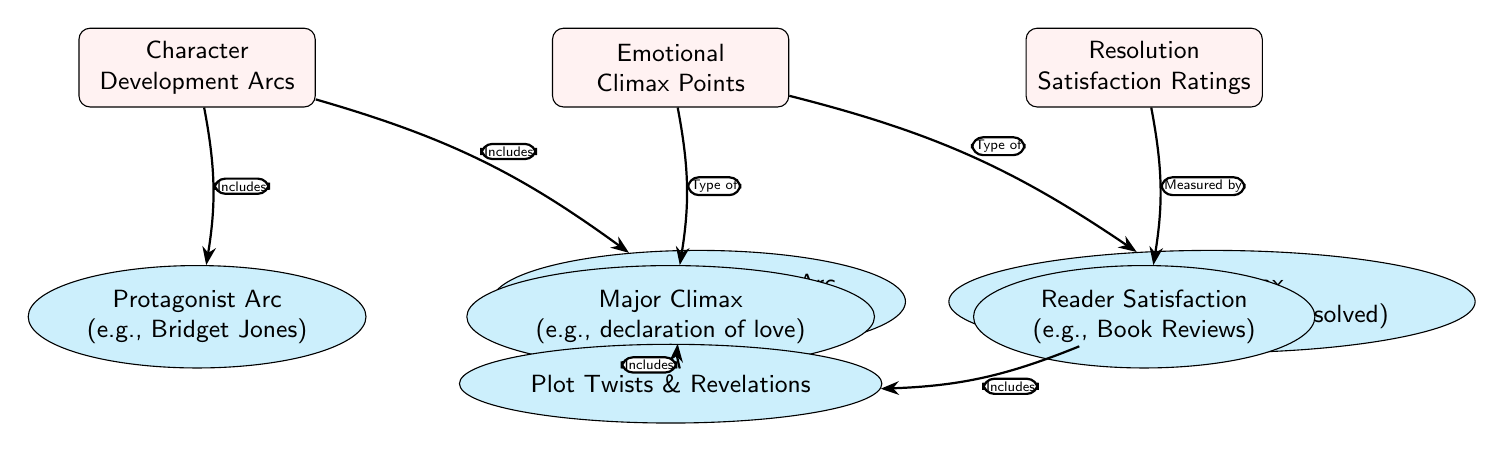What are the three main components highlighted in the diagram? The diagram features three main components which are labeled as Character Development Arcs, Emotional Climax Points, and Resolution Satisfaction Ratings. These main nodes represent the significant aspects of sentimentality score analysis in chick lit novels.
Answer: Character Development Arcs, Emotional Climax Points, Resolution Satisfaction Ratings What type of arcs is included in Character Development Arcs? Within the Character Development Arcs component, there are two specific types of arcs mentioned: Protagonist Arc (e.g., Bridget Jones) and Supporting Character Arc (e.g., Mr. Darcy). These denote the primary arcs focused on character growth.
Answer: Protagonist Arc, Supporting Character Arc How many types of emotional climax points are presented in the diagram? The Emotional Climax Points feature two types: Major Climax (e.g., declaration of love) and Minor Climax (e.g., misunderstanding resolved). Hence, there are two types shown in the diagram.
Answer: 2 What is the relationship between Major Climax and Plot Twists, according to the diagram? The diagram shows that the Major Climax includes Plot Twists & Revelations. This indicates that these plot twists and revelations are part of the overall climax in terms of character emotions and story development.
Answer: Includes What does Resolution Satisfaction Ratings measure? The diagram indicates that the Resolution Satisfaction Ratings are measured by Reader Satisfaction, which is exemplified by Book Reviews. This showcases the importance of reflecting reader feedback in determining satisfaction.
Answer: Reader Satisfaction What is a characteristic of Minor Climax points in the diagram? A characteristic of Minor Climax points is that they also include Plot Twists & Revelations, similar to Major Climax points. This emphasizes that both types of climax can contribute to narrative twists that affect emotional response.
Answer: Includes What edge-type connects Emotional Climax Points to Major Climax? The edge connecting Emotional Climax Points to Major Climax is labeled as "Type of". This relationship indicates the contextual relationship defining what comprises Emotional Climax Points.
Answer: Type of What is the total number of sub-nodes identified in the diagram? The diagram contains six sub-nodes: Protagonist Arc, Supporting Character Arc, Major Climax, Minor Climax, Reader Satisfaction, and Plot Twists & Revelations. Thus, the total is six.
Answer: 6 